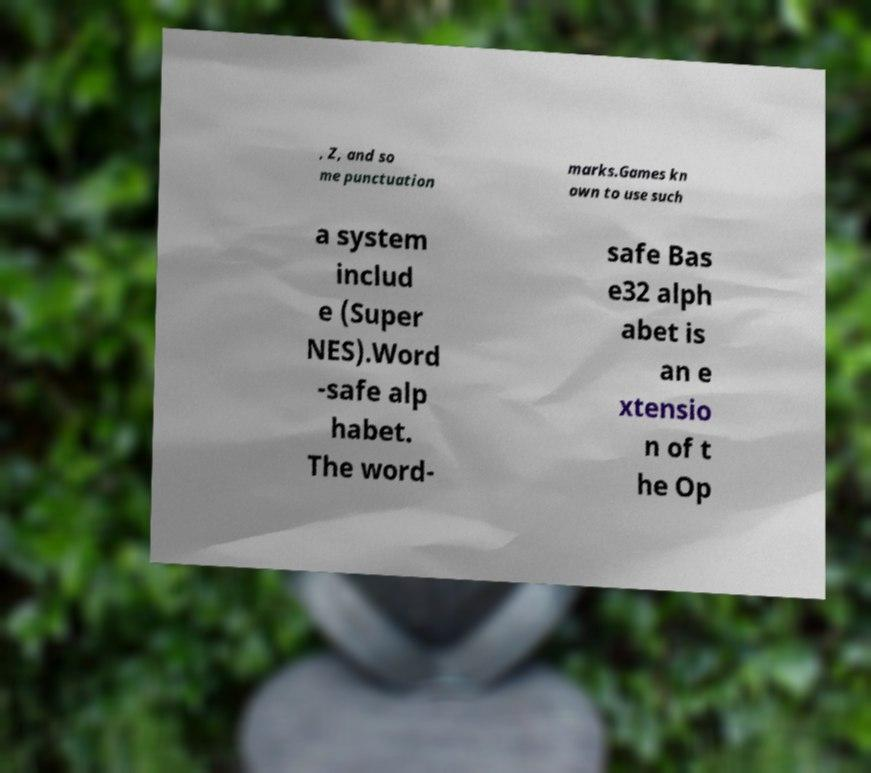I need the written content from this picture converted into text. Can you do that? , Z, and so me punctuation marks.Games kn own to use such a system includ e (Super NES).Word -safe alp habet. The word- safe Bas e32 alph abet is an e xtensio n of t he Op 